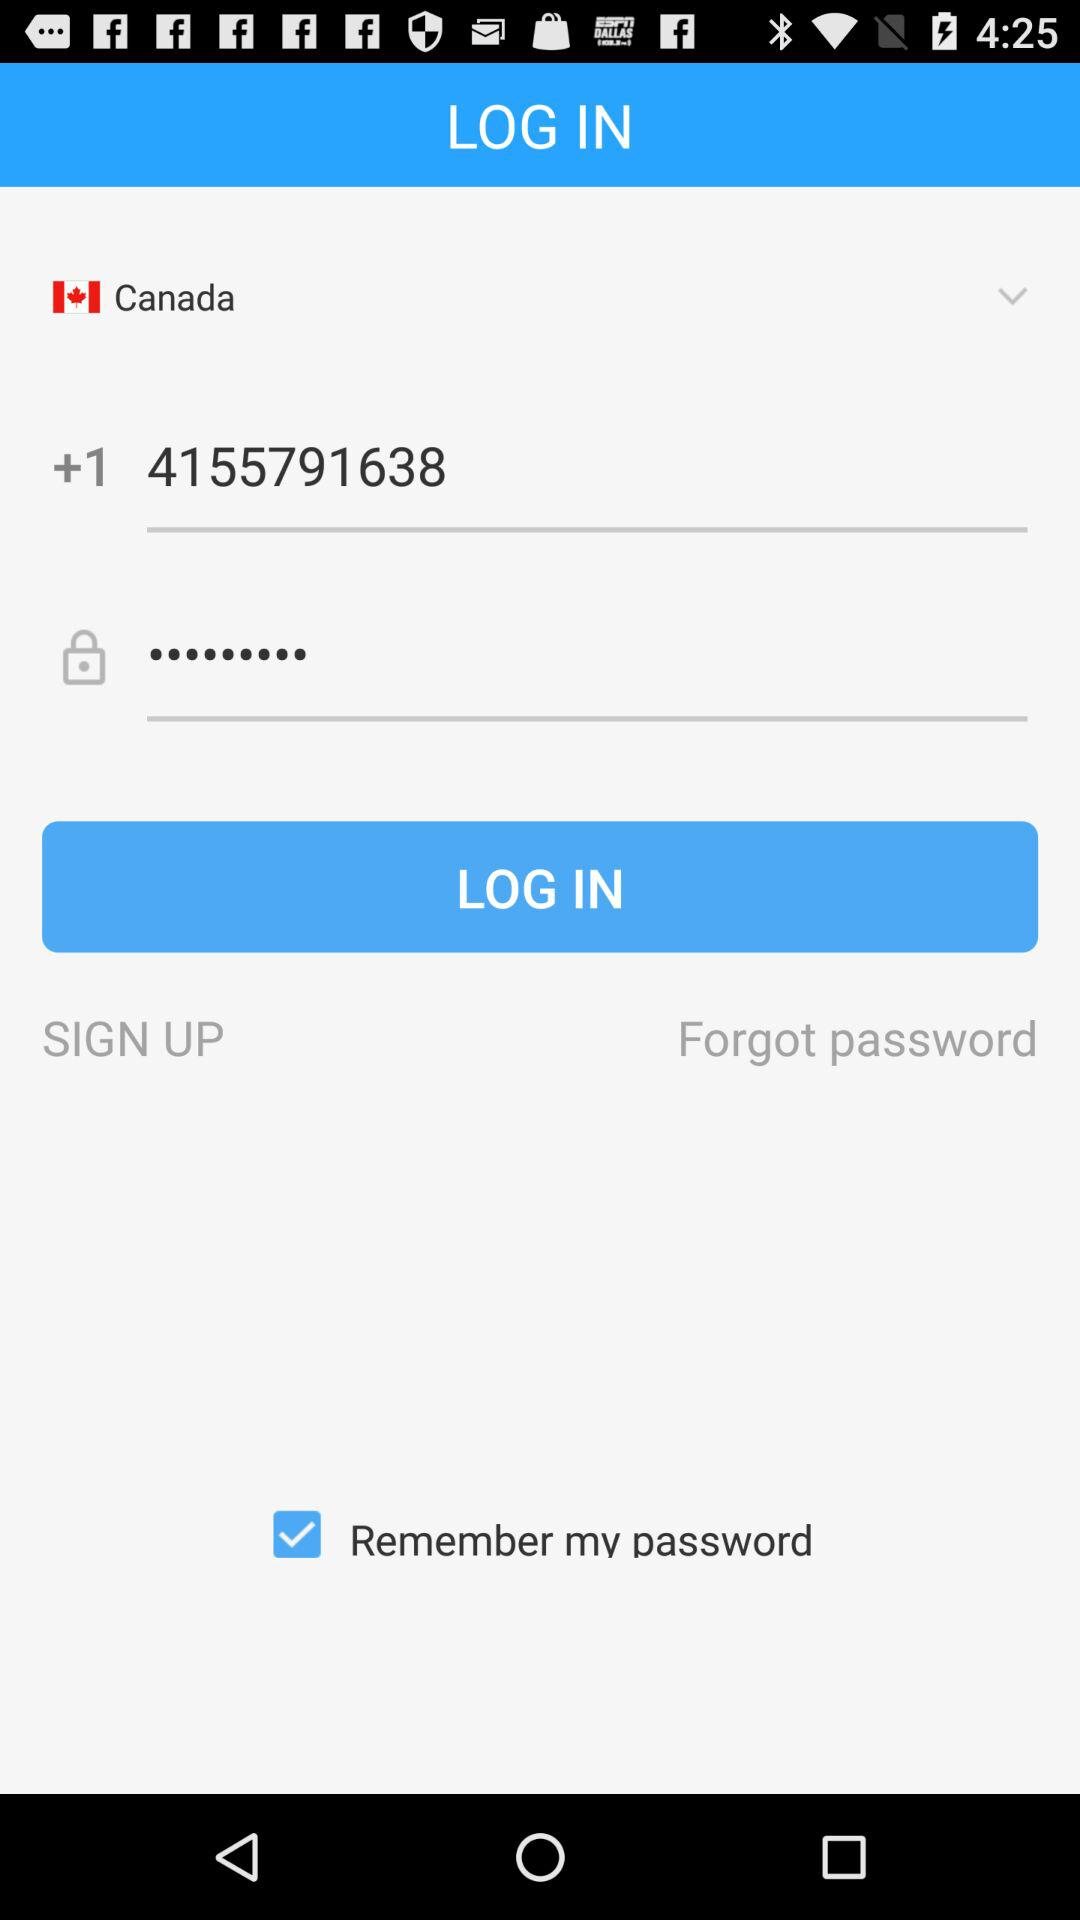How many text inputs have a country code?
Answer the question using a single word or phrase. 1 